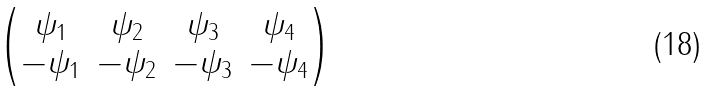<formula> <loc_0><loc_0><loc_500><loc_500>\begin{pmatrix} \psi _ { 1 } & \psi _ { 2 } & \psi _ { 3 } & \psi _ { 4 } \\ - \psi _ { 1 } & - \psi _ { 2 } & - \psi _ { 3 } & - \psi _ { 4 } \end{pmatrix}</formula> 